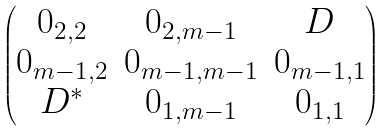Convert formula to latex. <formula><loc_0><loc_0><loc_500><loc_500>\begin{pmatrix} 0 _ { 2 , 2 } & 0 _ { 2 , m - 1 } & D \\ 0 _ { m - 1 , 2 } & 0 _ { m - 1 , m - 1 } & 0 _ { m - 1 , 1 } \\ D ^ { * } & 0 _ { 1 , m - 1 } & 0 _ { 1 , 1 } \end{pmatrix}</formula> 